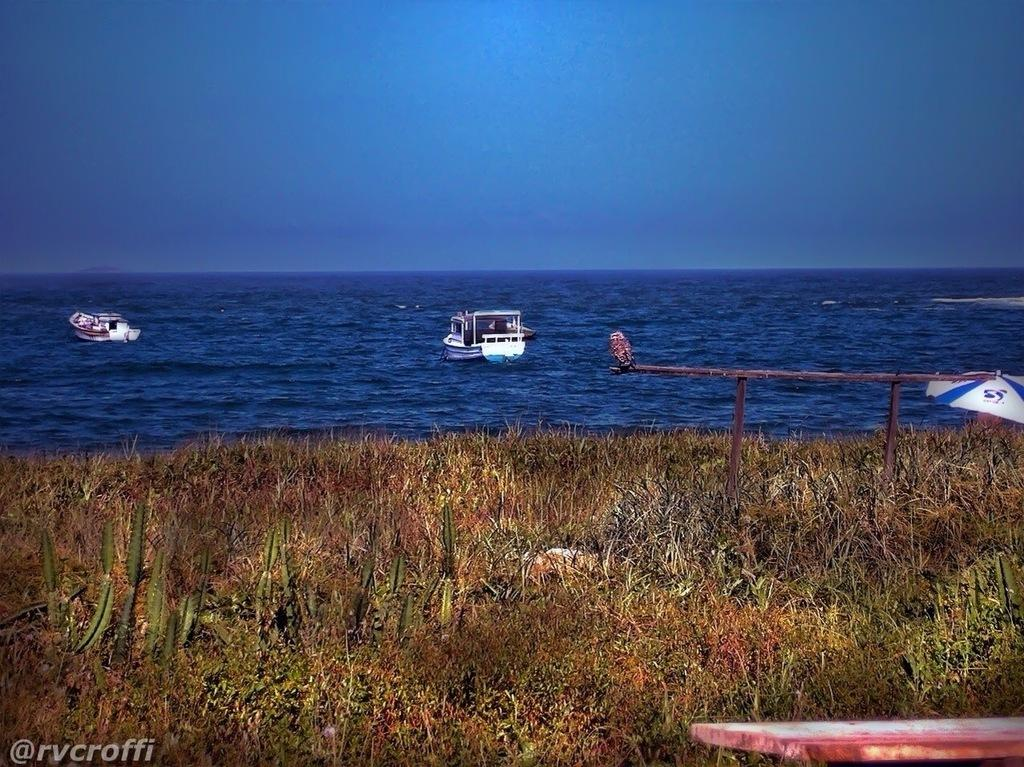What is located at the bottom of the image? There are plants at the bottom of the image. What can be seen in the middle of the image? There are boats on the water in the middle of the image. What is present in the bottom left-hand side of the image? There is a watermark in the bottom left-hand side of the image. What is visible at the top of the image? The sky is visible at the top of the image. Where is the shelf located in the image? There is no shelf present in the image. What type of wheel can be seen on the plants at the bottom of the image? There are no wheels present on the plants in the image. 